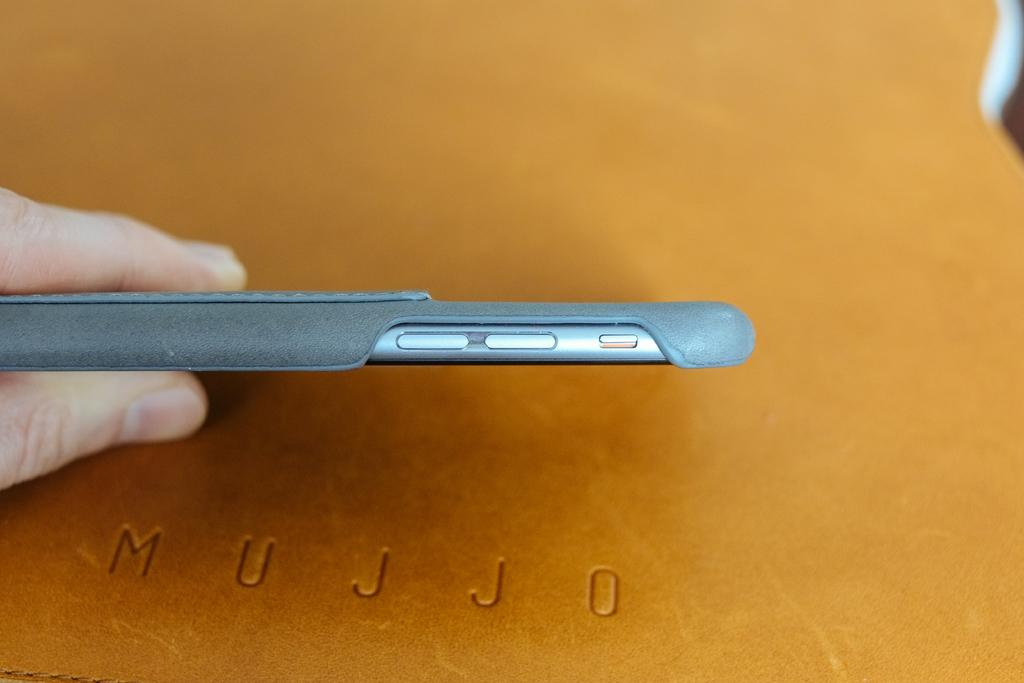<image>
Relay a brief, clear account of the picture shown. A hand holds a cellphone above a piece of leather embossed with Mujjo. 